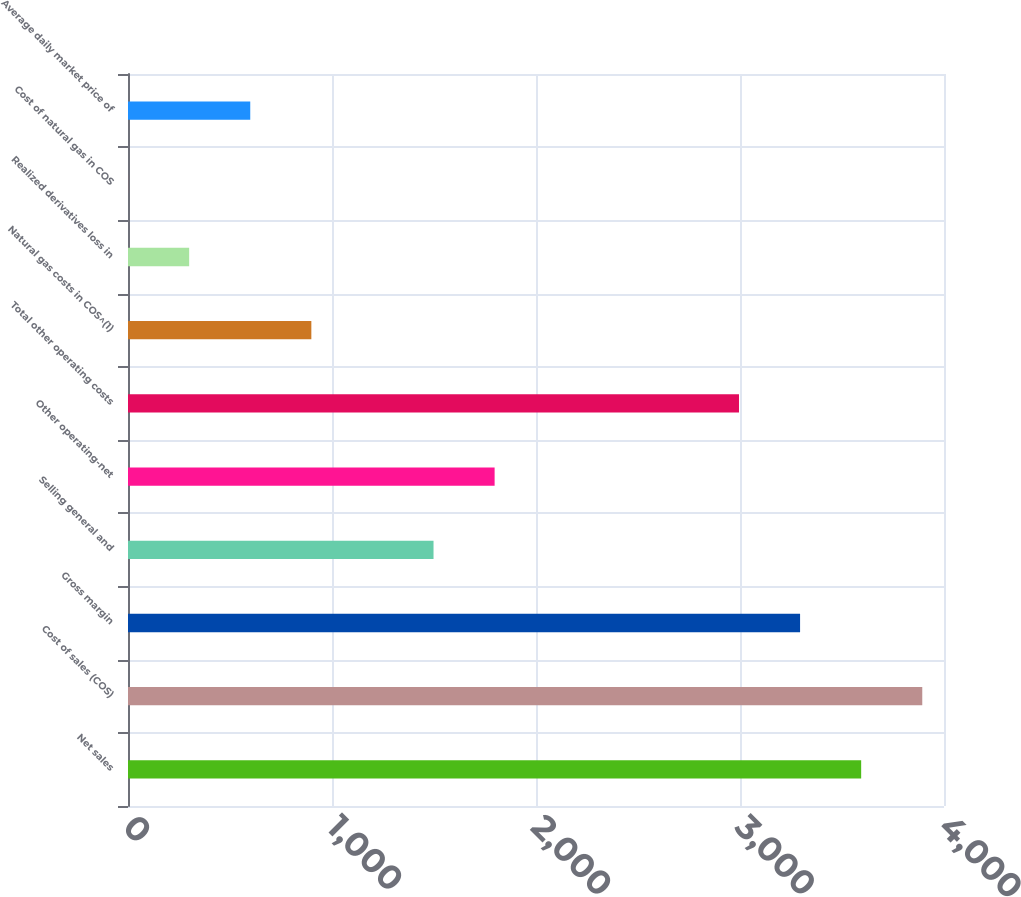Convert chart. <chart><loc_0><loc_0><loc_500><loc_500><bar_chart><fcel>Net sales<fcel>Cost of sales (COS)<fcel>Gross margin<fcel>Selling general and<fcel>Other operating-net<fcel>Total other operating costs<fcel>Natural gas costs in COS^(1)<fcel>Realized derivatives loss in<fcel>Cost of natural gas in COS<fcel>Average daily market price of<nl><fcel>3593.97<fcel>3893.44<fcel>3294.5<fcel>1497.68<fcel>1797.15<fcel>2995.03<fcel>898.74<fcel>299.8<fcel>0.33<fcel>599.27<nl></chart> 